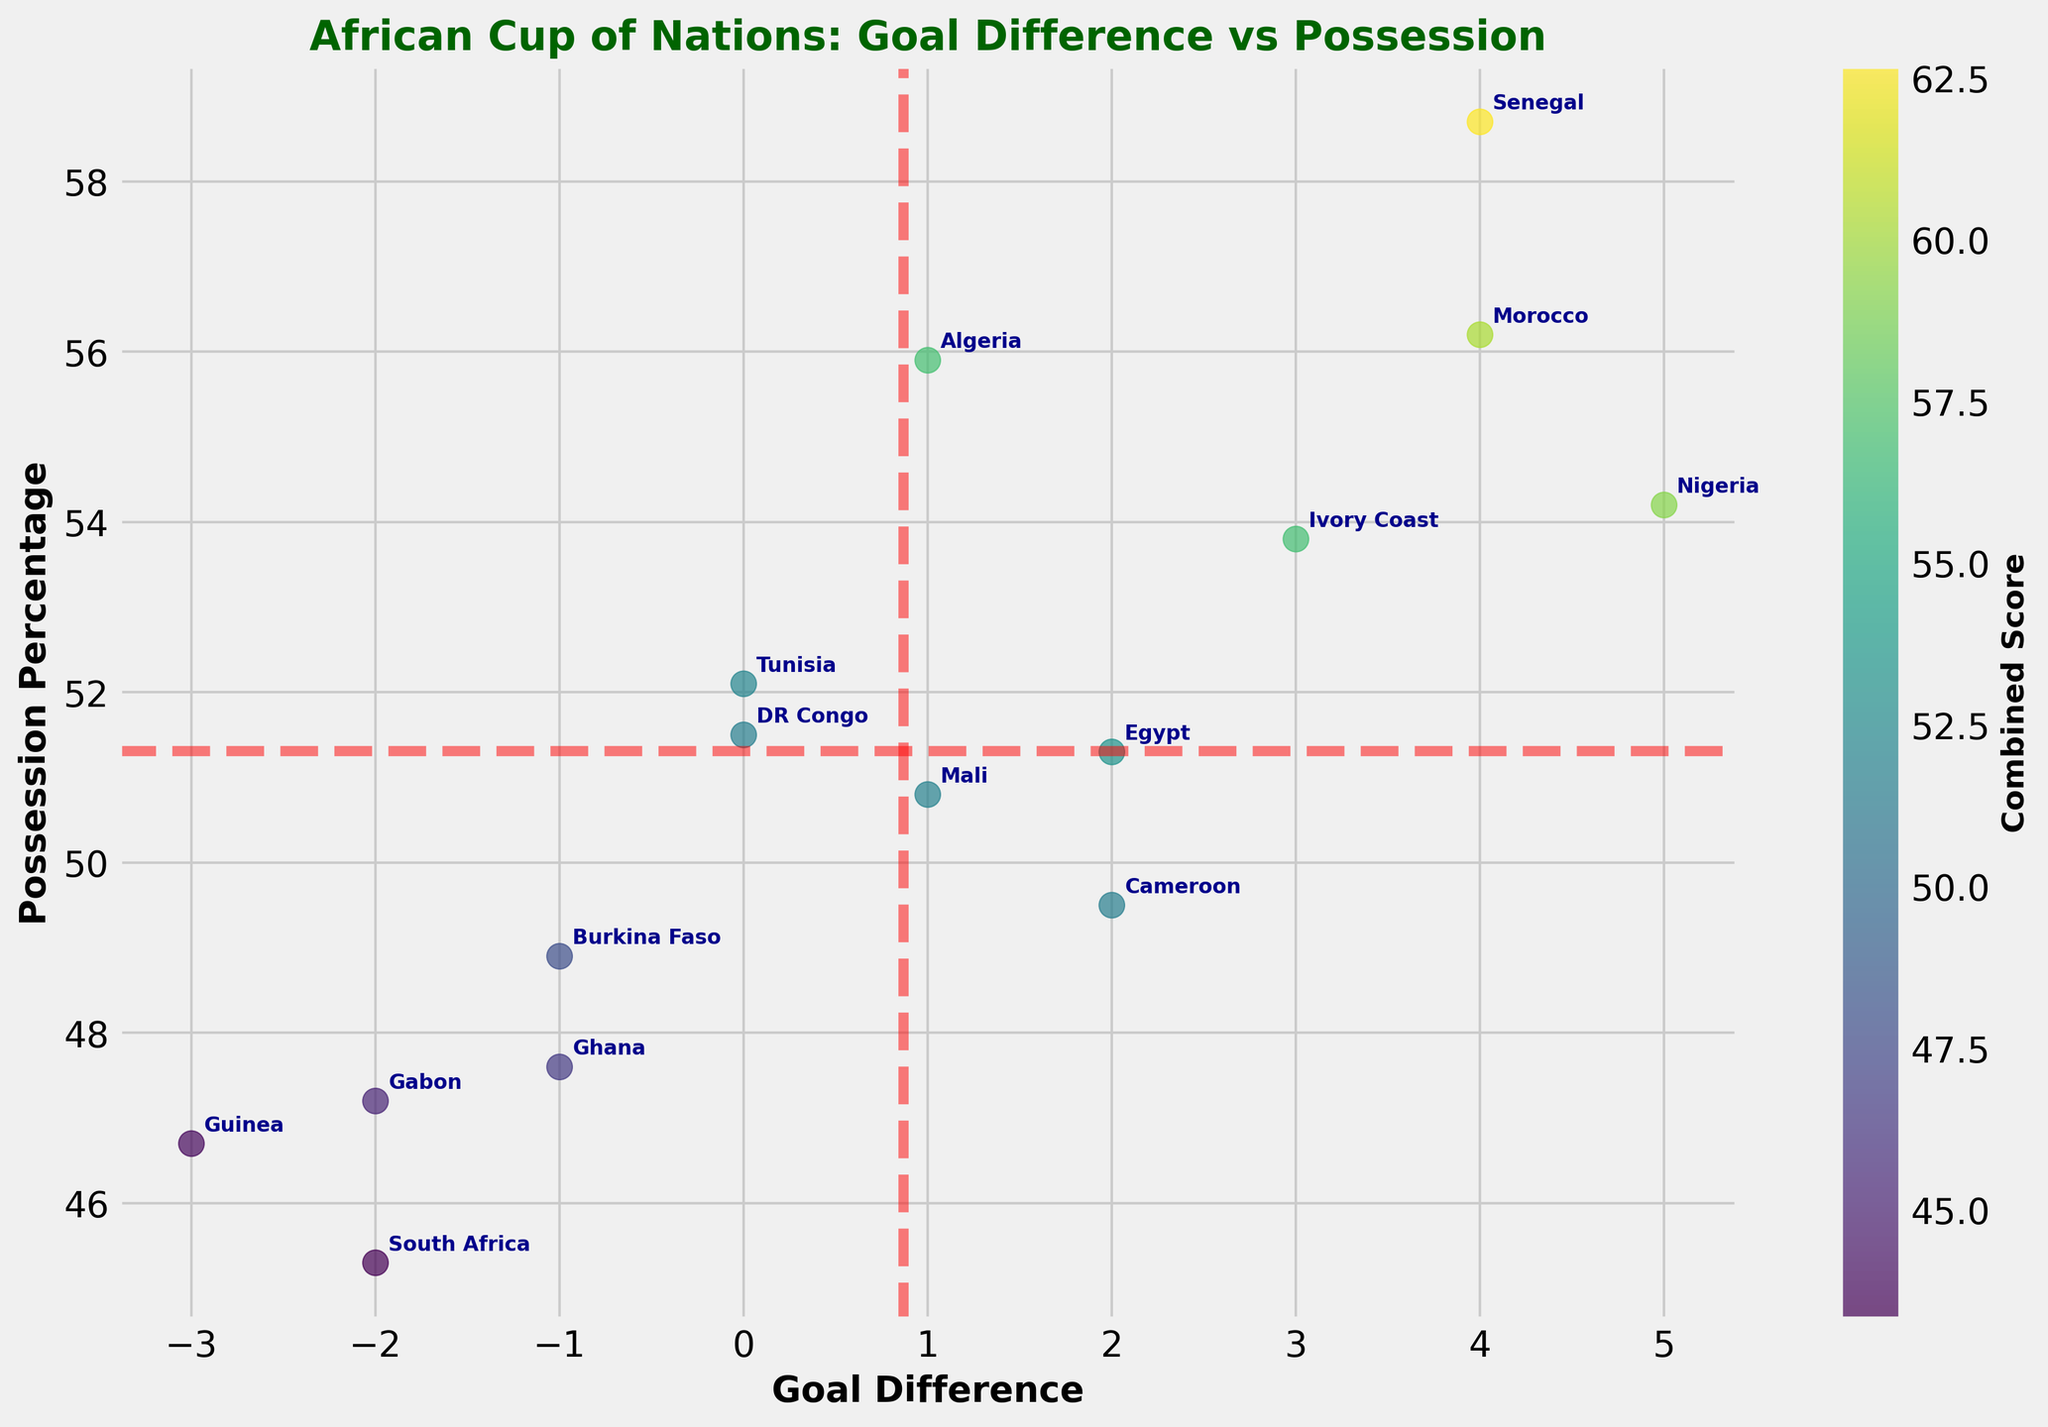How many teams are listed in the figure? Count the number of distinct data points or labels provided in the figure.
Answer: 15 Which team has the highest possession percentage? Identify the team with the highest y-axis value (Possession Percentage).
Answer: Senegal Which team has the lowest goal difference? Identify the team with the lowest x-axis value (Goal Difference).
Answer: Guinea What is the average possession percentage of all teams? Calculate the mean of all 'Possession_Percentage' values: (54.2 + 58.7 + 51.3 + 53.8 + 47.6 + 55.9 + 49.5 + 56.2 + 52.1 + 50.8 + 45.3 + 48.9 + 46.7 + 47.2 + 51.5)/15 = 51.6367.
Answer: 51.64 Which quadrant does Nigeria fall into? Compare Nigeria's values to the mean values of goal difference and possession percentage to determine the quadrant where x > x_mean and y > y_mean.
Answer: Upper Right How many teams have a goal difference greater than 2? Count the number of teams with a 'Goal_Difference' value greater than 2.
Answer: 4 Which team(s) fall in the same quadrant as Nigeria? Determine which teams are in the upper-right quadrant where both goal difference and possession percentage are above their respective means.
Answer: Senegal, Morocco, Ivory Coast What's the combined score of Morocco and Ghana? Sum the values of goal difference and possession percentage for both Morocco and Ghana: (4 + 56.2) + (-1 + 47.6) = 60.2 + 46.6 = 106.8.
Answer: 106.8 Which teams are below average in both goal difference and possession percentage? Identify teams whose values are both below the mean for goal difference and possession percentage.
Answer: South Africa, Gabon, Guinea What is the difference in possession percentage between Senegal and South Africa? Subtract South Africa's possession percentage from Senegal's: 58.7 - 45.3 = 13.4.
Answer: 13.4 